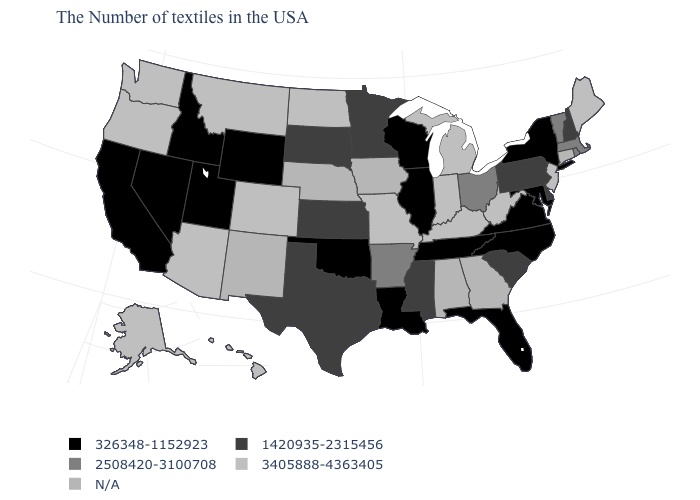Which states hav the highest value in the Northeast?
Answer briefly. Maine, New Jersey. Is the legend a continuous bar?
Answer briefly. No. What is the value of Arizona?
Give a very brief answer. 3405888-4363405. Is the legend a continuous bar?
Concise answer only. No. Among the states that border Indiana , which have the highest value?
Give a very brief answer. Michigan, Kentucky. Name the states that have a value in the range 2508420-3100708?
Give a very brief answer. Massachusetts, Rhode Island, Vermont, Ohio, Arkansas. Name the states that have a value in the range 3405888-4363405?
Quick response, please. Maine, New Jersey, West Virginia, Michigan, Kentucky, Indiana, Missouri, North Dakota, Colorado, Montana, Arizona, Washington, Oregon, Alaska, Hawaii. Which states have the highest value in the USA?
Concise answer only. Maine, New Jersey, West Virginia, Michigan, Kentucky, Indiana, Missouri, North Dakota, Colorado, Montana, Arizona, Washington, Oregon, Alaska, Hawaii. Name the states that have a value in the range 2508420-3100708?
Quick response, please. Massachusetts, Rhode Island, Vermont, Ohio, Arkansas. Is the legend a continuous bar?
Write a very short answer. No. Name the states that have a value in the range 2508420-3100708?
Quick response, please. Massachusetts, Rhode Island, Vermont, Ohio, Arkansas. Does the first symbol in the legend represent the smallest category?
Answer briefly. Yes. What is the value of Georgia?
Short answer required. N/A. How many symbols are there in the legend?
Write a very short answer. 5. 